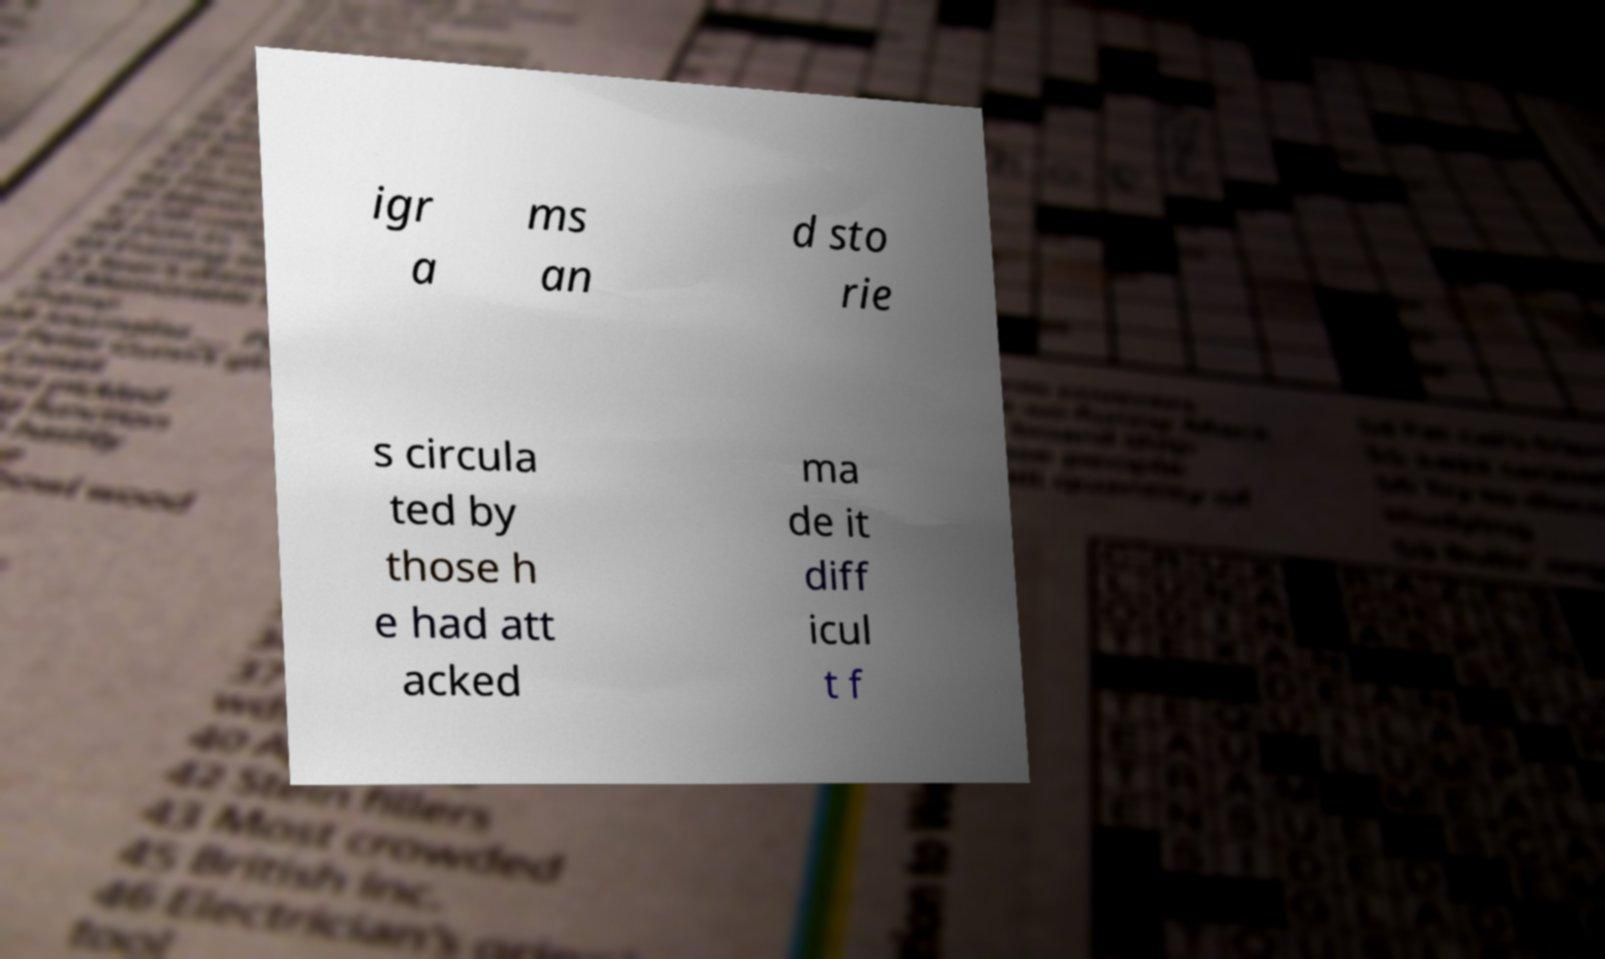Please read and relay the text visible in this image. What does it say? igr a ms an d sto rie s circula ted by those h e had att acked ma de it diff icul t f 